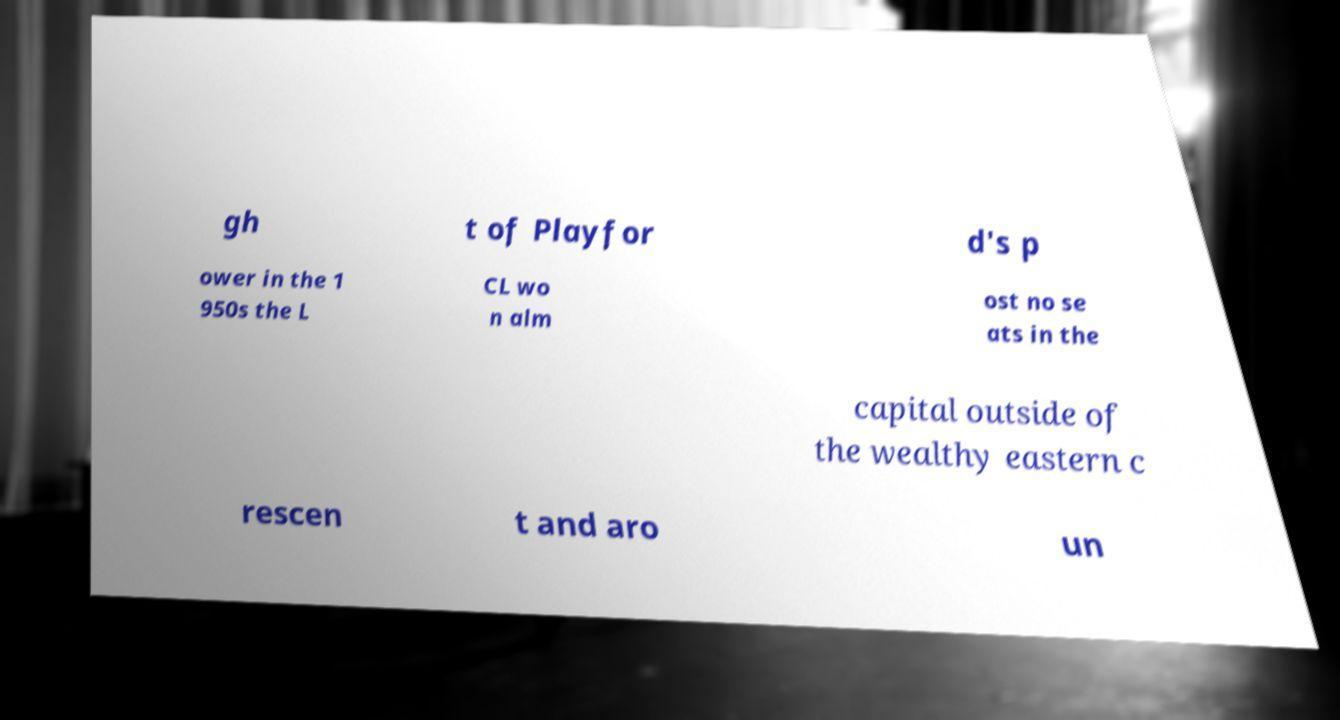Could you extract and type out the text from this image? gh t of Playfor d's p ower in the 1 950s the L CL wo n alm ost no se ats in the capital outside of the wealthy eastern c rescen t and aro un 